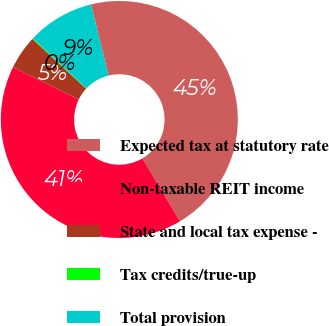<chart> <loc_0><loc_0><loc_500><loc_500><pie_chart><fcel>Expected tax at statutory rate<fcel>Non-taxable REIT income<fcel>State and local tax expense -<fcel>Tax credits/true-up<fcel>Total provision<nl><fcel>45.31%<fcel>40.82%<fcel>4.62%<fcel>0.13%<fcel>9.12%<nl></chart> 